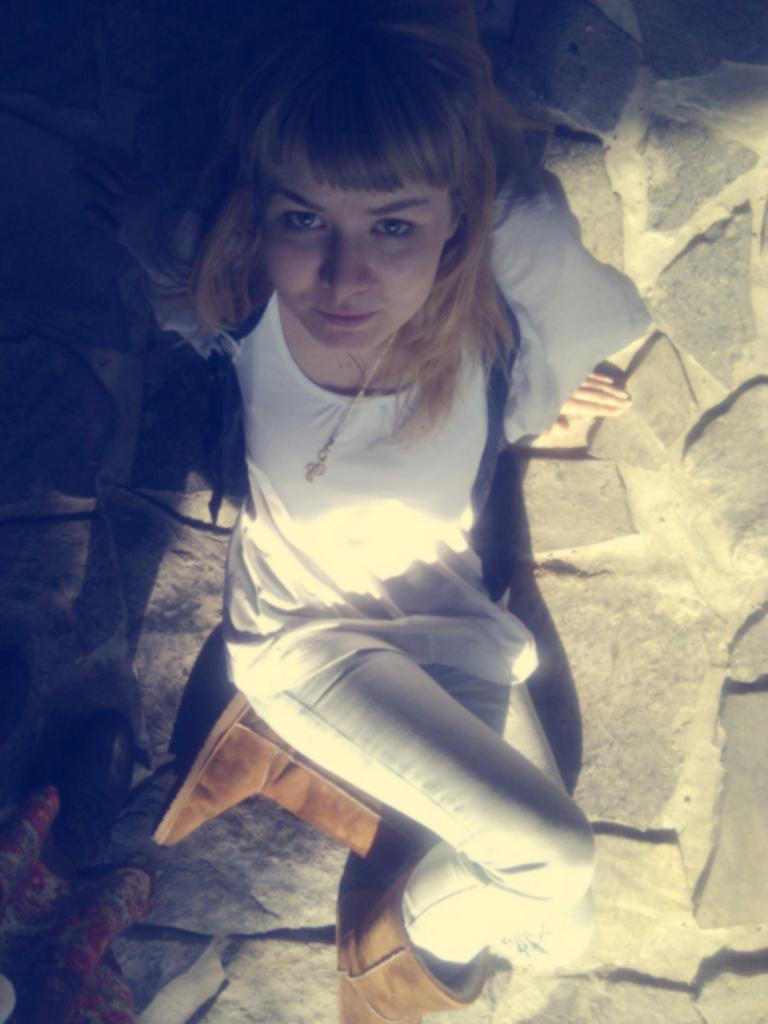Where was the image taken? The image was taken outdoors. What is at the bottom of the image? There is a floor at the bottom of the image. What can be seen in the middle of the image? There is a girl sitting on the floor in the middle of the image. What type of connection can be seen between the girl and the kitten in the image? There is no kitten present in the image, so there is no connection between the girl and a kitten. 